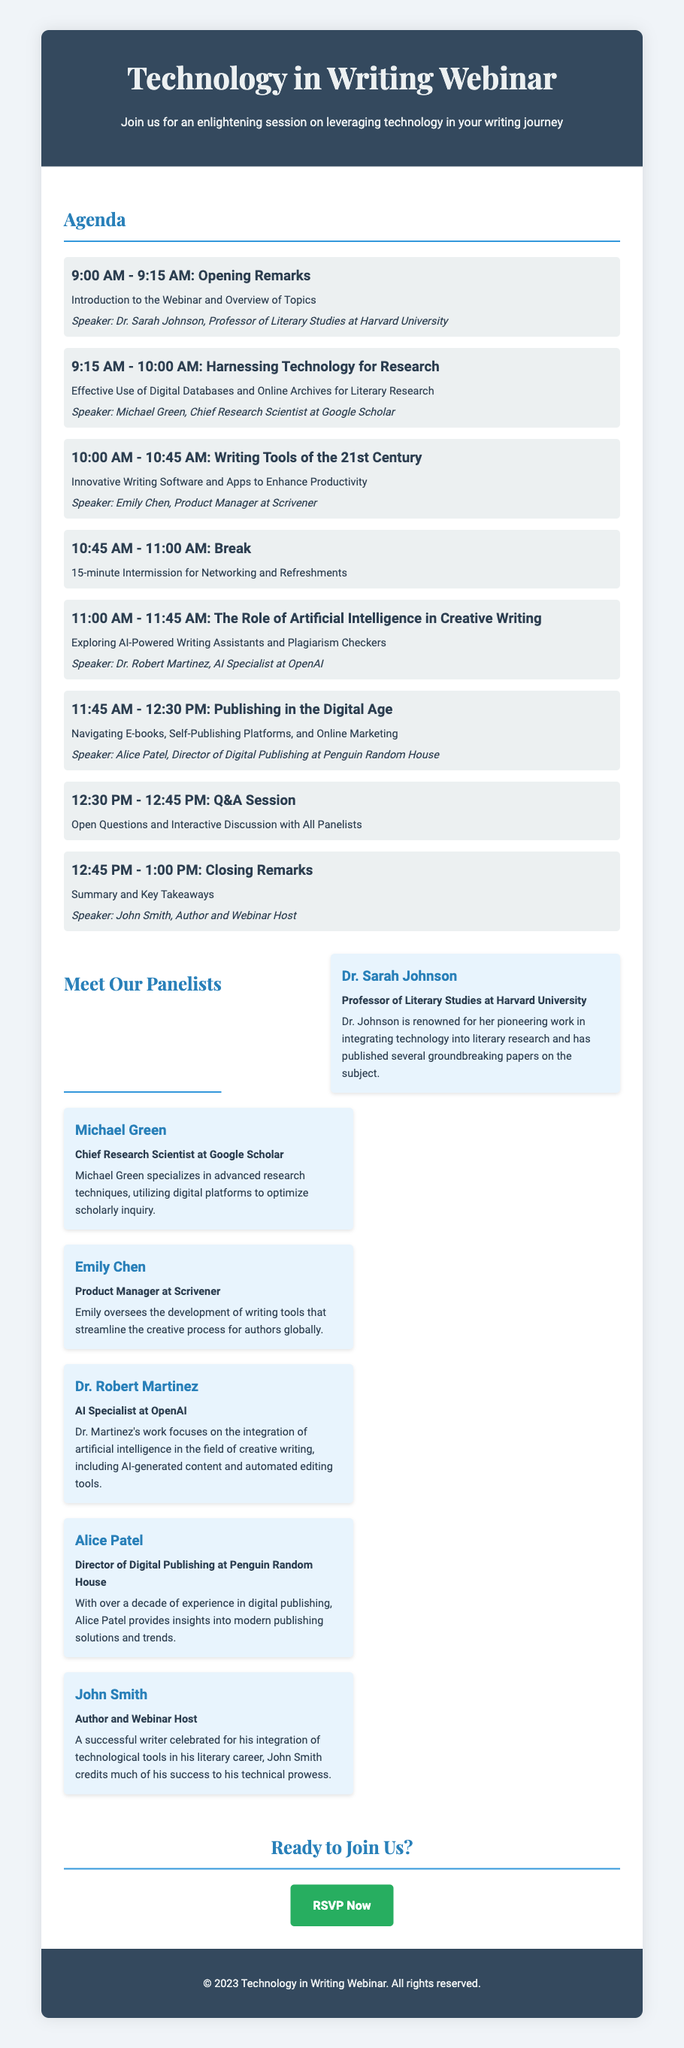What is the title of the webinar? The title of the webinar is prominently displayed at the top of the document.
Answer: Technology in Writing Webinar Who is the speaker for the session on AI in Creative Writing? The speaker's name is mentioned alongside the session topic in the agenda section.
Answer: Dr. Robert Martinez What time does the Q&A Session start? The time for the Q&A Session is listed in the agenda.
Answer: 12:30 PM How many panelists are featured in the webinar? The number of panelists can be counted from the section that introduces each panelist.
Answer: Six What is the main focus of Michael Green's session? The focus is outlined in the session description next to his name in the agenda.
Answer: Harnessing Technology for Research What is the link to register for the webinar? The RSVP button section provides the registration link at the bottom of the document.
Answer: https://www.techwritingwebinar.com/register What type of intermission is scheduled in the agenda? The type of event during the break is described under the scheduled break in the agenda.
Answer: Networking and Refreshments Which university is Dr. Sarah Johnson affiliated with? Her affiliation is found in her introduction in the panelists section.
Answer: Harvard University 